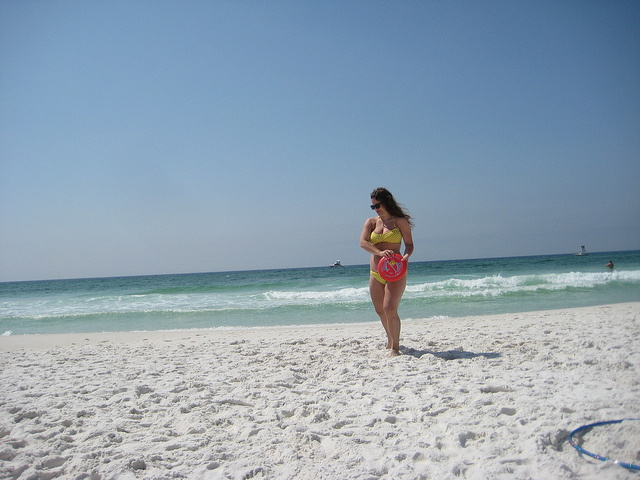Can you describe the weather conditions at the beach? The weather appears to be sunny with a clear sky, suggesting a warm and pleasant day perfect for beachgoers. The sunlight is bright, casting soft shadows on the sand, while the sea reflects the sun's light, indicating it's likely midday. 